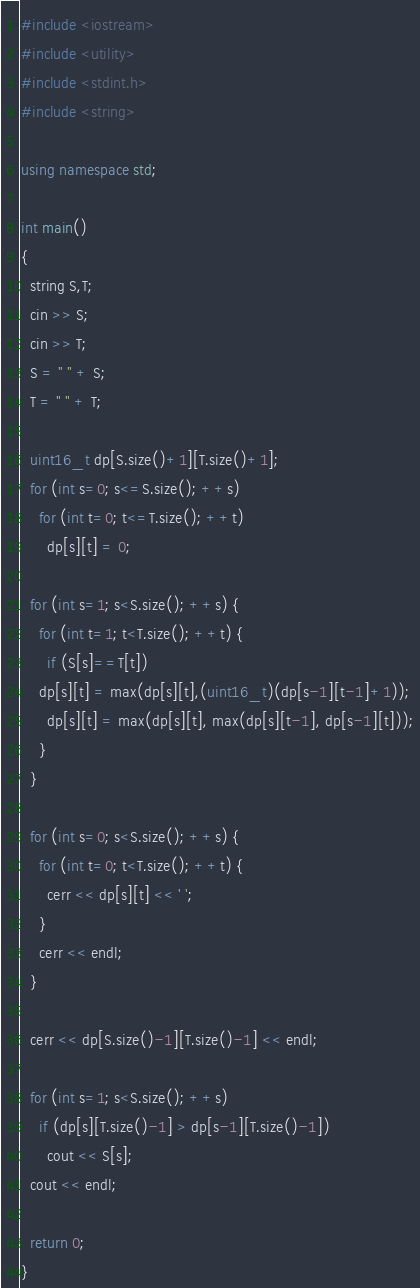Convert code to text. <code><loc_0><loc_0><loc_500><loc_500><_C++_>#include <iostream>
#include <utility>
#include <stdint.h>
#include <string>

using namespace std;

int main()
{
  string S,T;
  cin >> S;
  cin >> T;
  S = " " + S;
  T = " " + T;

  uint16_t dp[S.size()+1][T.size()+1];
  for (int s=0; s<=S.size(); ++s)
    for (int t=0; t<=T.size(); ++t)
      dp[s][t] = 0;

  for (int s=1; s<S.size(); ++s) {
    for (int t=1; t<T.size(); ++t) {
      if (S[s]==T[t])
	dp[s][t] = max(dp[s][t],(uint16_t)(dp[s-1][t-1]+1));
      dp[s][t] = max(dp[s][t], max(dp[s][t-1], dp[s-1][t]));
    }
  }

  for (int s=0; s<S.size(); ++s) {
    for (int t=0; t<T.size(); ++t) {
      cerr << dp[s][t] << ' ';
    }
    cerr << endl;
  }

  cerr << dp[S.size()-1][T.size()-1] << endl;

  for (int s=1; s<S.size(); ++s)
    if (dp[s][T.size()-1] > dp[s-1][T.size()-1])
      cout << S[s];
  cout << endl;
  
  return 0;
}
</code> 